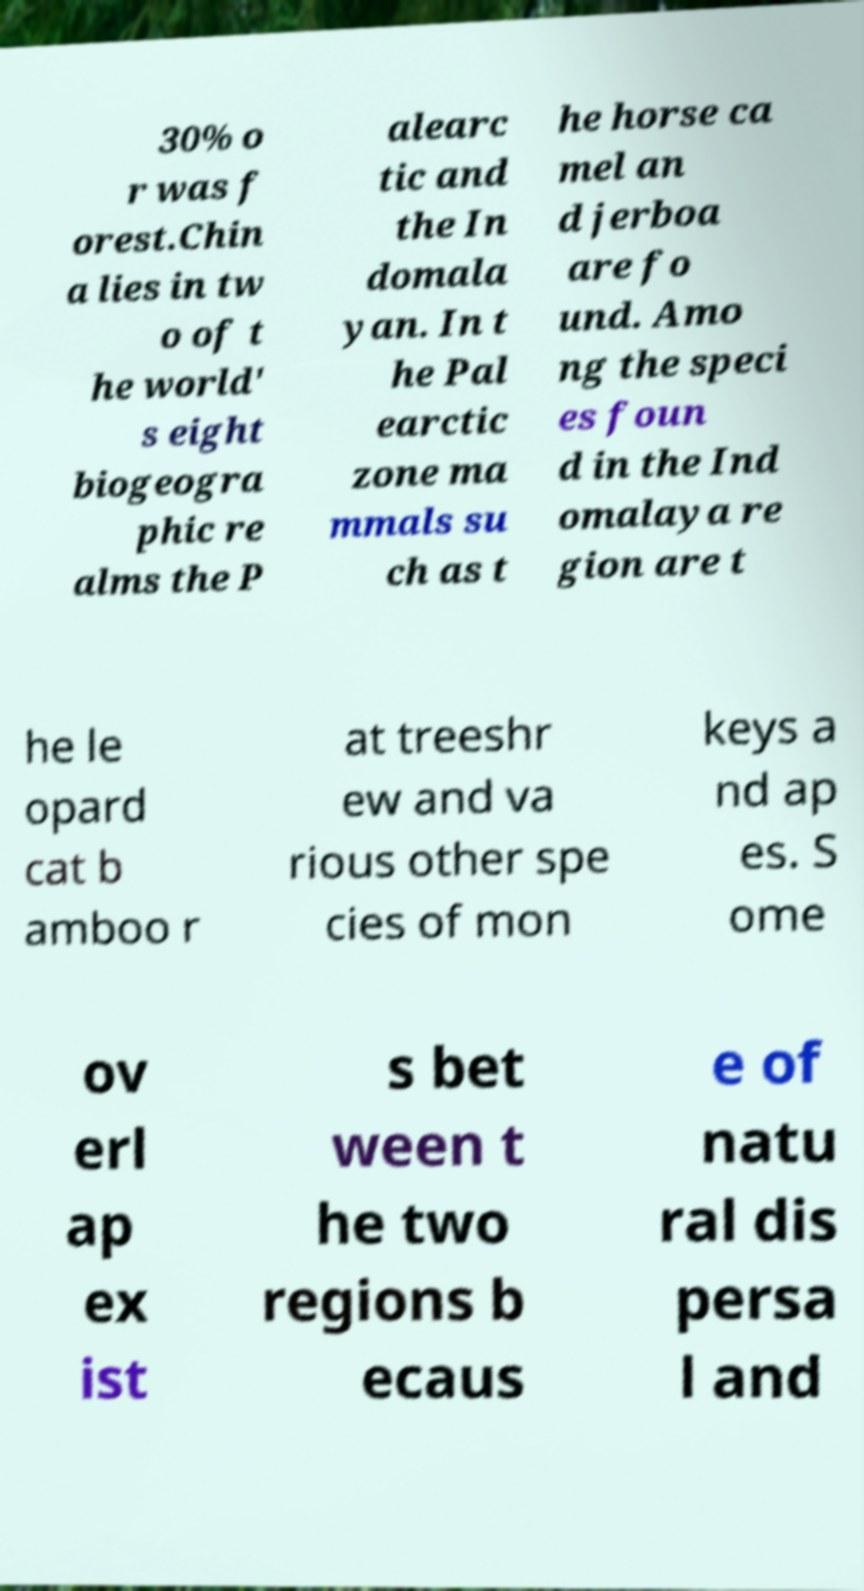What messages or text are displayed in this image? I need them in a readable, typed format. 30% o r was f orest.Chin a lies in tw o of t he world' s eight biogeogra phic re alms the P alearc tic and the In domala yan. In t he Pal earctic zone ma mmals su ch as t he horse ca mel an d jerboa are fo und. Amo ng the speci es foun d in the Ind omalaya re gion are t he le opard cat b amboo r at treeshr ew and va rious other spe cies of mon keys a nd ap es. S ome ov erl ap ex ist s bet ween t he two regions b ecaus e of natu ral dis persa l and 